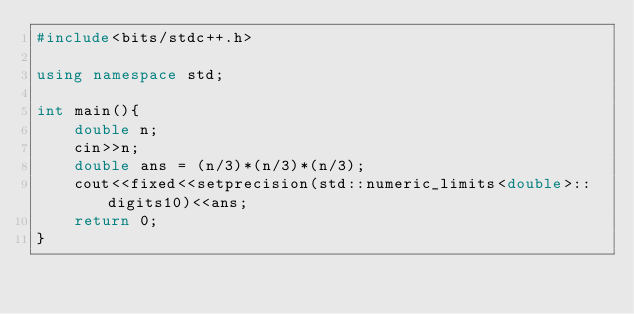Convert code to text. <code><loc_0><loc_0><loc_500><loc_500><_C++_>#include<bits/stdc++.h>

using namespace std;

int main(){
    double n;
    cin>>n;
    double ans = (n/3)*(n/3)*(n/3);
    cout<<fixed<<setprecision(std::numeric_limits<double>::digits10)<<ans;
    return 0;
}
</code> 